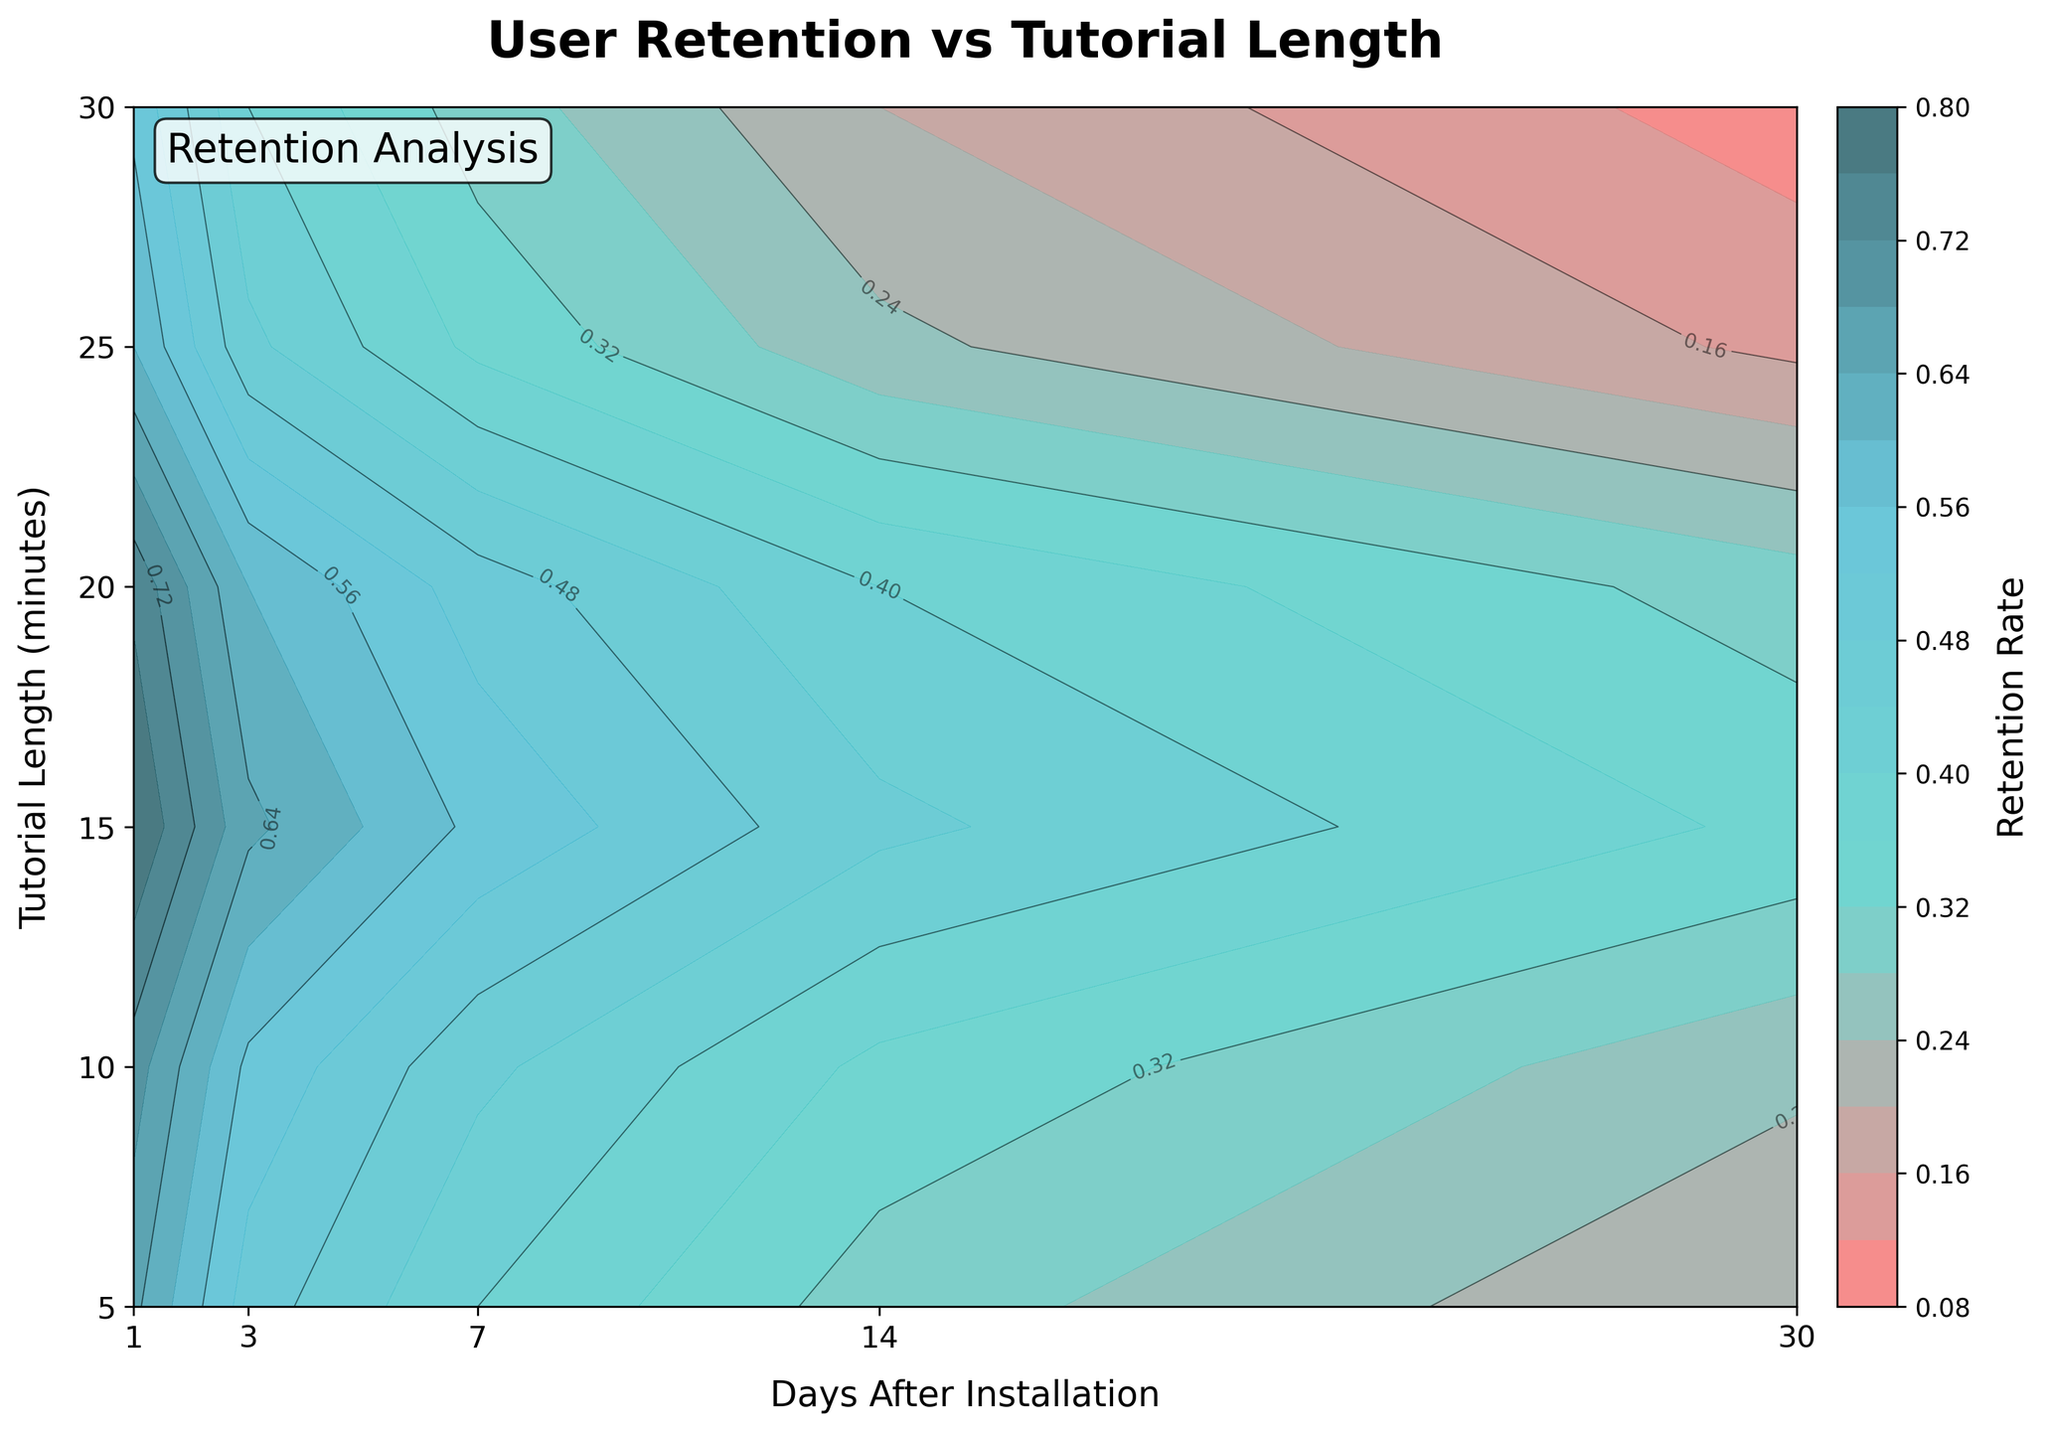What is the title of the plot? The title is clearly labeled at the top of the plot.
Answer: User Retention vs Tutorial Length What is the retention rate for a tutorial length of 15 minutes on day 7? Find the value where tutorial length is 15 minutes and intersect it with day 7 retention rate.
Answer: 0.55 Which tutorial length shows the highest retention rate on day 1? Compare the retention rates for different tutorial lengths and identify the highest one on day 1.
Answer: 15 minutes What is the trend in retention rate over time for a tutorial length of 25 minutes? Observe the contour plot lines and see how retention rates change from day 1 to day 30 for 25 minutes.
Answer: The retention rate decreases over time Which day has the lowest retention rate for a tutorial length of 10 minutes? Check the retention rates for the tutorial length of 10 minutes and identify the lowest value among the days.
Answer: Day 30 Is there a tutorial length that consistently retains users better than others over all days? Compare the retention rates across all tutorial lengths over all days to identify if any tutorial length retains users better consistently.
Answer: 15 minutes How does the retention rate on day 14 compare between tutorial lengths of 5 minutes and 30 minutes? Look at the retention rate for day 14 at tutorial lengths of 5 and 30 minutes and compare these two values.
Answer: 0.30 for 5 minutes and 0.20 for 30 minutes What is the general pattern of the contour lines in the plot? Examine the shape and direction of the contour lines to identify patterns in retention rates.
Answer: The contour lines generally show higher retention rates for mid-range tutorial lengths (10 to 20 minutes) and lower rates for both shorter and longer tutorials Which day shows the steepest decline in retention rate for a tutorial length of 20 minutes? Observe the slope of retention rate changes from day to day for the tutorial length of 20 minutes and identify the steepest decline.
Answer: Day 7 to Day 14 